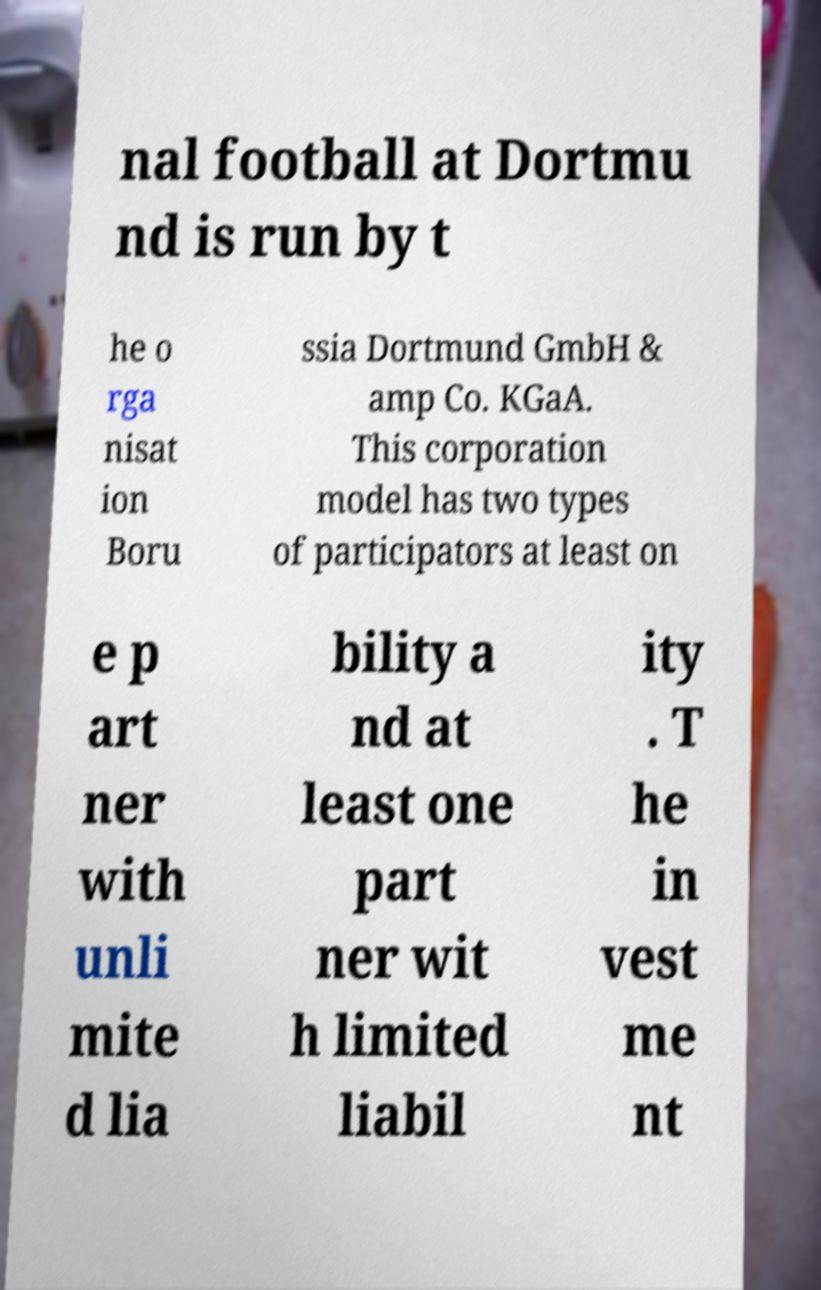Could you assist in decoding the text presented in this image and type it out clearly? nal football at Dortmu nd is run by t he o rga nisat ion Boru ssia Dortmund GmbH & amp Co. KGaA. This corporation model has two types of participators at least on e p art ner with unli mite d lia bility a nd at least one part ner wit h limited liabil ity . T he in vest me nt 